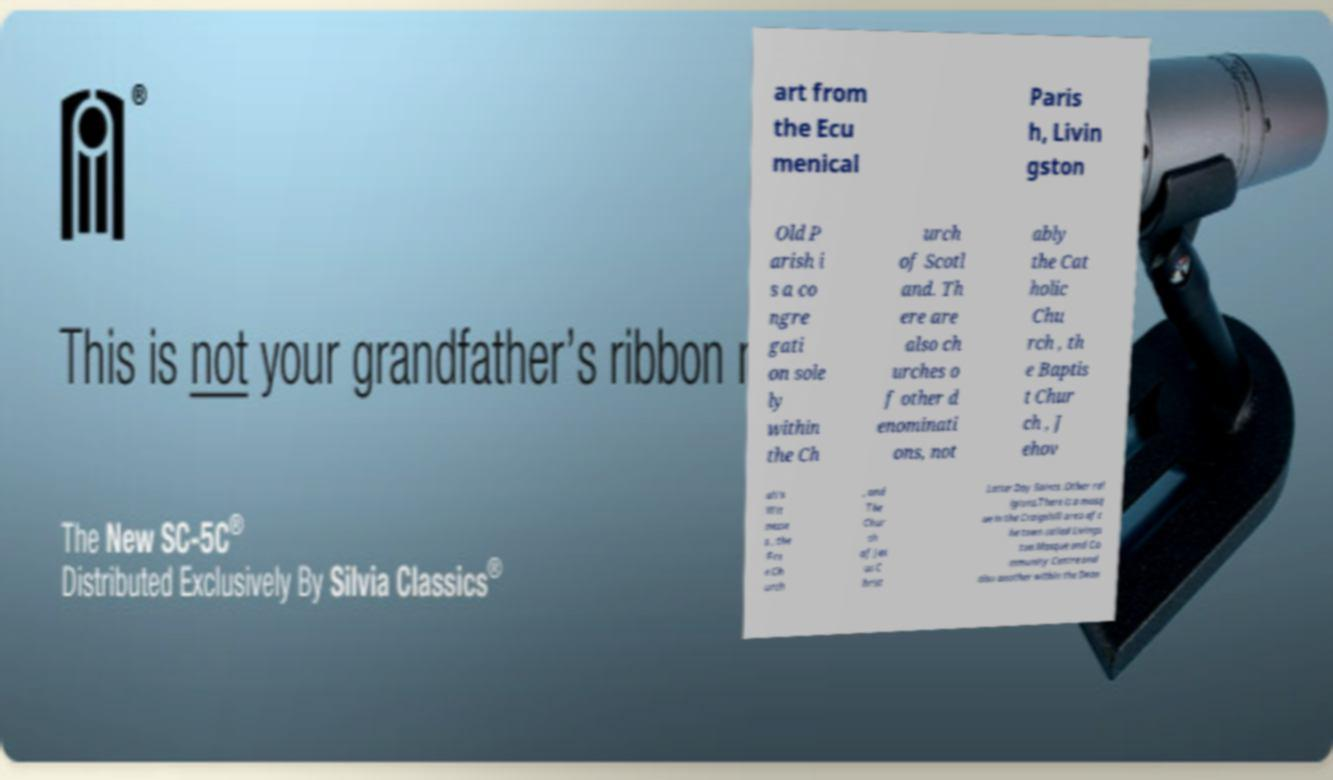Please identify and transcribe the text found in this image. art from the Ecu menical Paris h, Livin gston Old P arish i s a co ngre gati on sole ly within the Ch urch of Scotl and. Th ere are also ch urches o f other d enominati ons, not ably the Cat holic Chu rch , th e Baptis t Chur ch , J ehov ah's Wit nesse s , the Fre e Ch urch , and The Chur ch of Jes us C hrist Latter Day Saints .Other rel igions.There is a mosq ue in the Craigshill area of t he town called Livings ton Mosque and Co mmunity Centre and also another within the Dean 